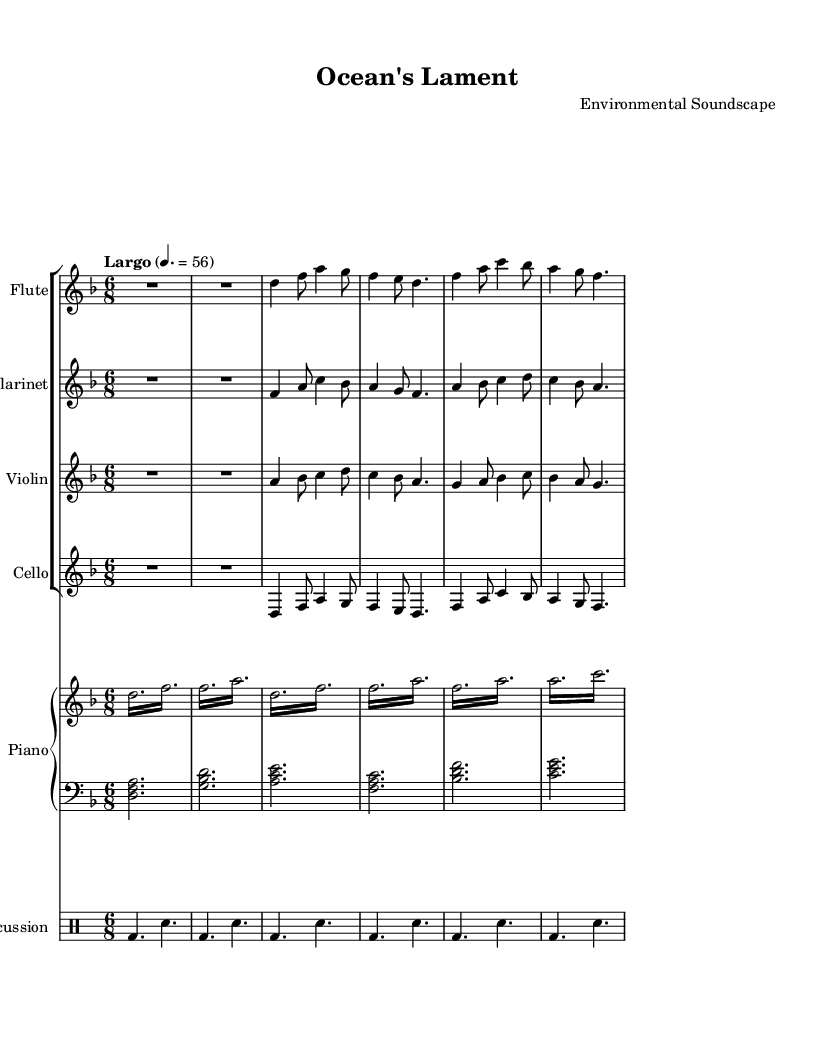What is the key signature of this music? The key signature is indicated at the beginning of the staff where the sharps or flats appear. Here, there are one flat (B♭), which indicates it is in D minor.
Answer: D minor What is the time signature of this composition? The time signature is located at the beginning of the sheet music. It shows "6/8," indicating that there are six eighth notes per measure.
Answer: 6/8 What is the tempo marking for this piece? The tempo marking, which specifies the speed, appears above the staff. It states "Largo," with a metronome marking of 56, indicating a slow speed.
Answer: Largo 4. = 56 Which instruments are included in this score? The instruments can be identified by their respective staves labeled at the beginning of each staff. The score includes flute, clarinet, violin, cello, piano, and percussion.
Answer: Flute, clarinet, violin, cello, piano, percussion How many measures are in the flute part? To find the number of measures, count the distinct vertical lines that separate the measures in the flute part. There are six measures present in the flute part.
Answer: 6 How do the pitches in the left hand of the piano part relate to the right hand? The left hand plays chordal patterns indicated by the simultaneous grouping of notes, while the right hand plays melodic figures. The two parts create a contrast that enriches the texture of the music. This relationship creates harmonic support for the melody in the right hand.
Answer: Contrapuntal interaction 